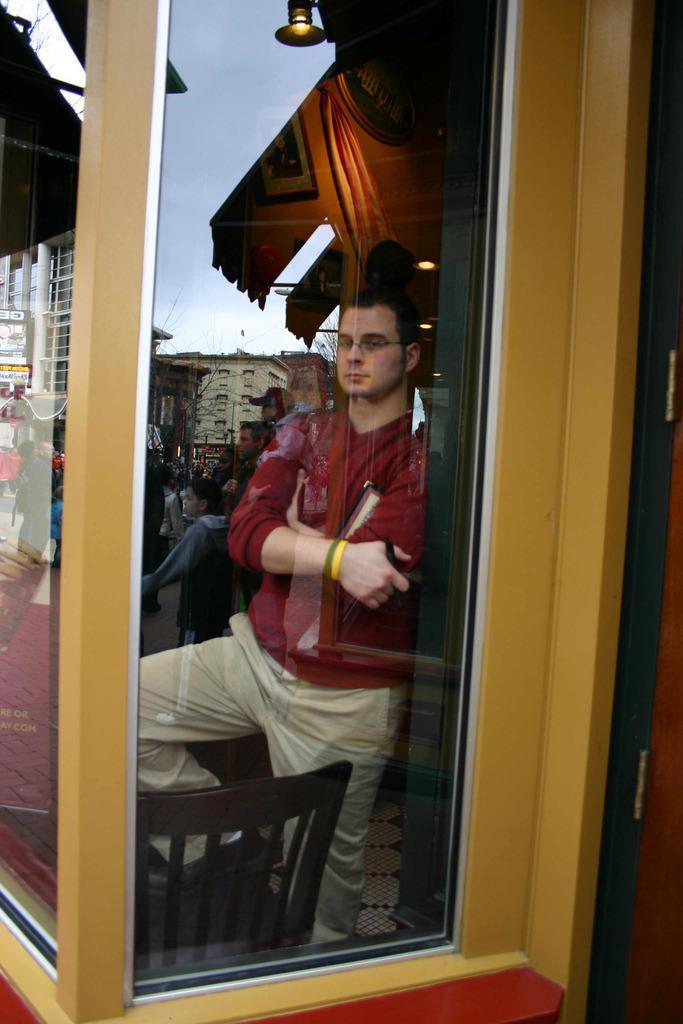Describe this image in one or two sentences. There is a man standing beside the glass wall beside wooden pillar. 